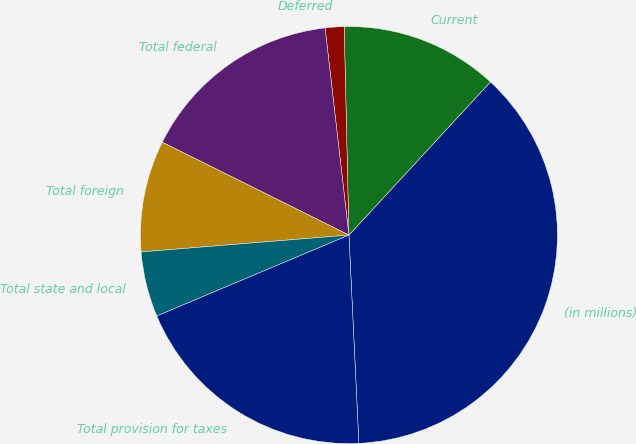Convert chart to OTSL. <chart><loc_0><loc_0><loc_500><loc_500><pie_chart><fcel>(in millions)<fcel>Current<fcel>Deferred<fcel>Total federal<fcel>Total foreign<fcel>Total state and local<fcel>Total provision for taxes<nl><fcel>37.36%<fcel>12.23%<fcel>1.46%<fcel>15.82%<fcel>8.64%<fcel>5.05%<fcel>19.41%<nl></chart> 